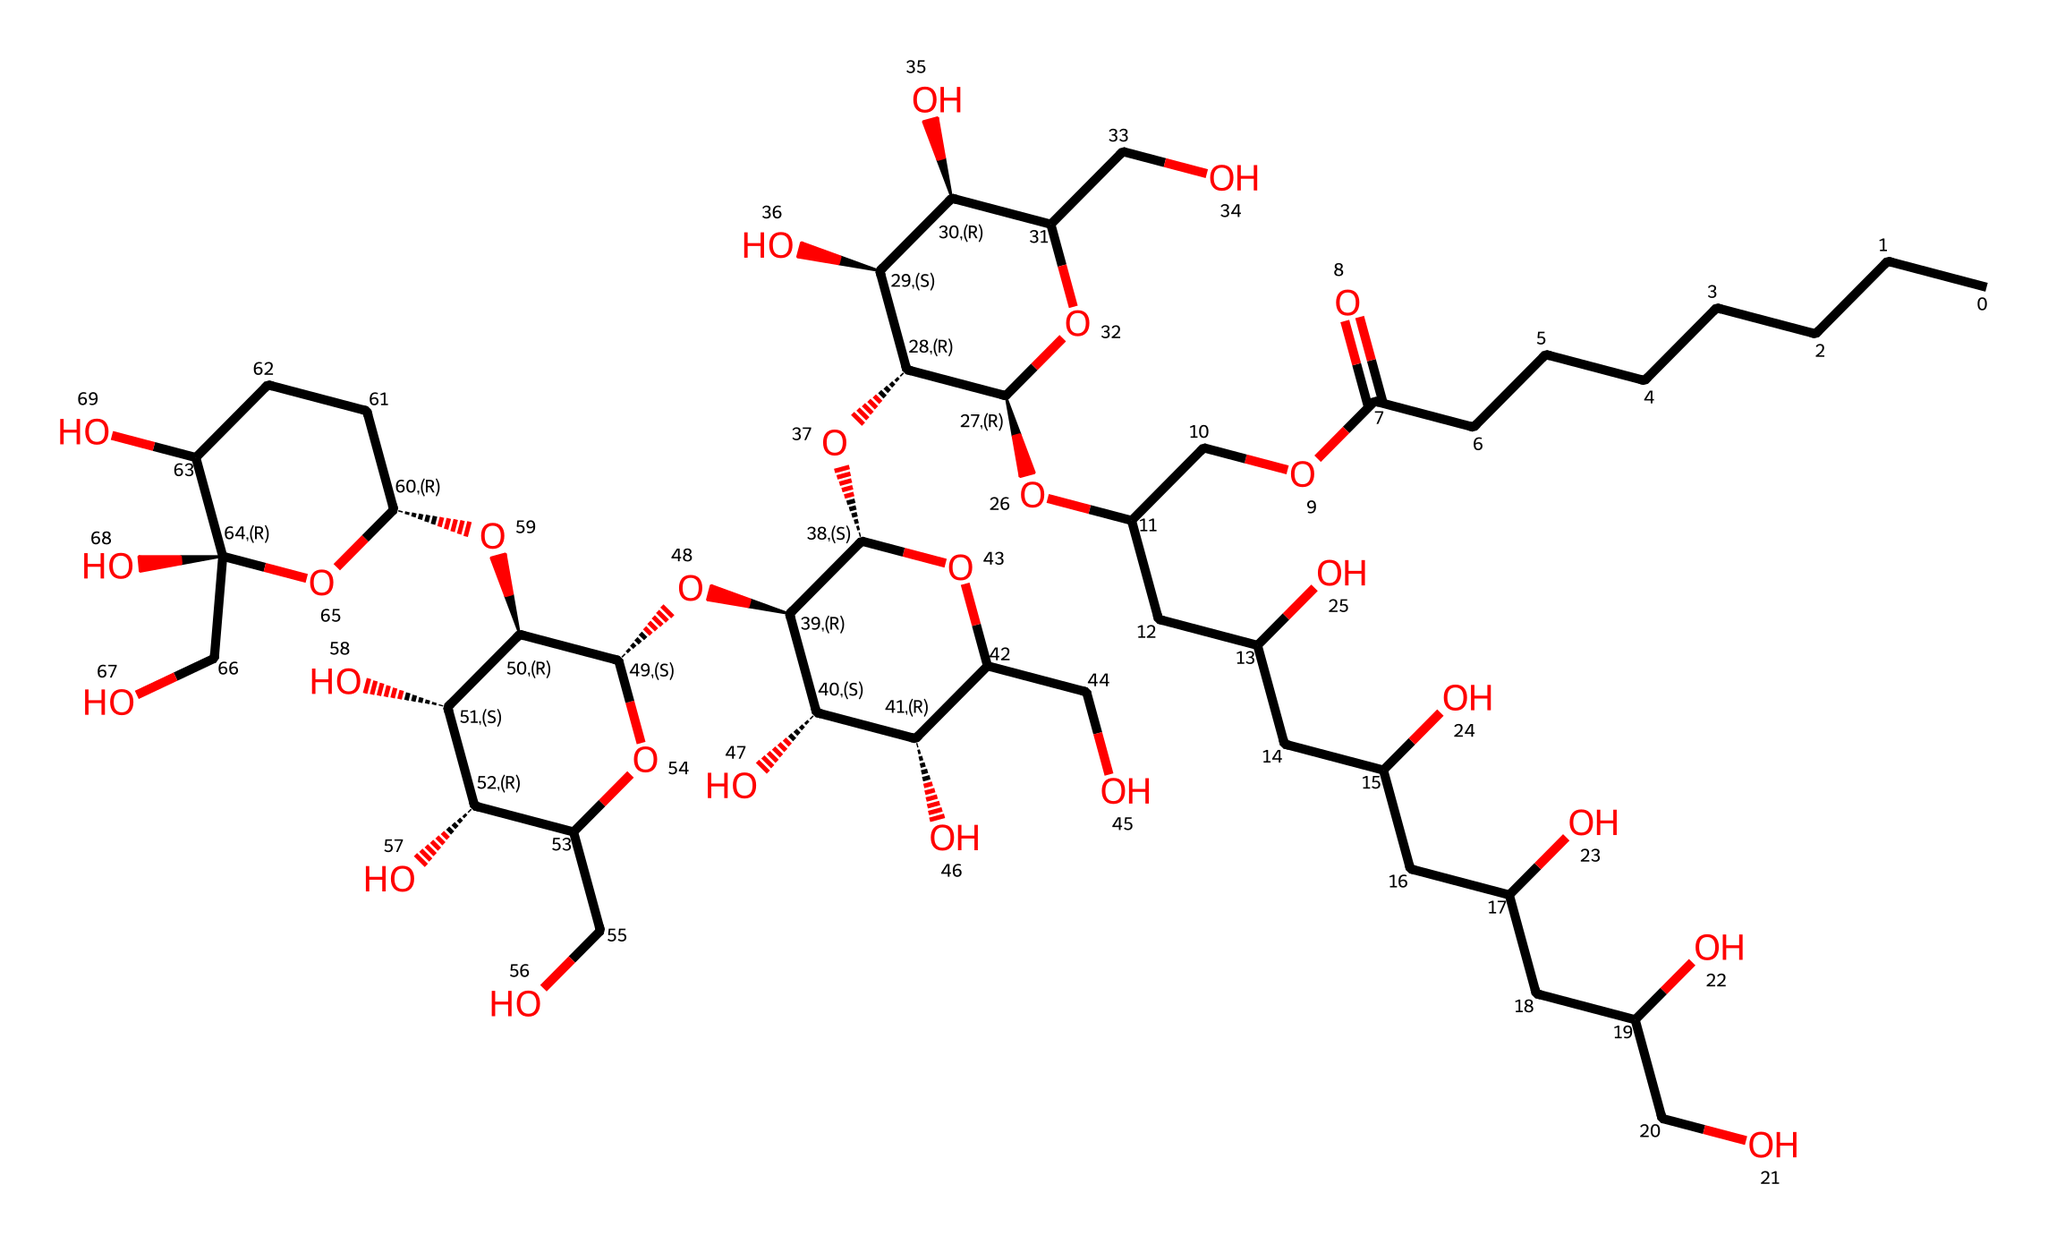What is the molecular formula of polysorbate 80? To determine the molecular formula, we analyze the given SMILES representation and count the number of carbon (C), hydrogen (H), and oxygen (O) atoms. By parsing through the structure, we see there are 80 carbons, 160 hydrogens, and 20 oxygens. Thus, the molecular formula can be summarized as C80H160O20.
Answer: C80H160O20 How many hydroxyl (–OH) groups are present in polysorbate 80? A hydroxyl group is identified within the structure by looking for instances of the –OH functional group, which indicates alcohol functionality. By counting the distinct –OH groups in the SMILES, we find there are 16 of these groups attached to various carbon atoms throughout the molecule.
Answer: 16 What is the role of polysorbate 80 in sports drinks? Polysorbate 80 functions mainly as an emulsifier in sports drinks. It helps to stabilize mixtures of oil and water, ensuring that ingredients are evenly dispersed throughout the liquid, which is critical for the mouthfeel and absorption of nutrients.
Answer: emulsifier What type of surfactant is polysorbate 80 classified as? Analyzing the structure, polysorbate 80 is a nonionic surfactant because it contains no charge and has hydrophobic (water-repelling) and hydrophilic (water-attracting) parts, which allow it to reduce surface tension effectively.
Answer: nonionic Based on the chemical structure, how many rings are present in polysorbate 80? By evaluating the provided SMILES, we can identify cyclic structures by looking for brackets and connections that indicate ring formation. In this case, there are four distinct ring structures indicated within the sequence.
Answer: 4 How does polysorbate 80 enhance the stability of a sports drink? Polysorbate 80 contains both hydrophilic and hydrophobic segments, enabling it to interact with both water and oil-based ingredients. This duality helps create a stable emulsion, preventing separation over time and improving the drink's texture and consistency.
Answer: prevents separation 